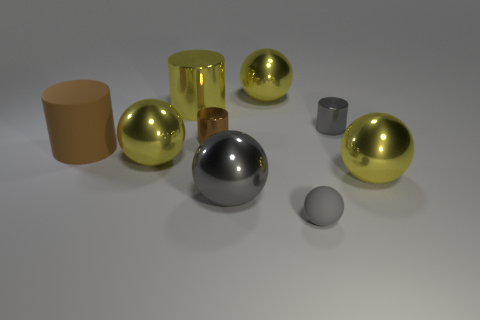Subtract all tiny gray cylinders. How many cylinders are left? 3 Subtract all blue cylinders. Subtract all brown cubes. How many cylinders are left? 4 Subtract all cyan balls. How many purple cylinders are left? 0 Subtract all gray things. Subtract all matte cylinders. How many objects are left? 5 Add 2 brown shiny cylinders. How many brown shiny cylinders are left? 3 Add 4 tiny cyan rubber cubes. How many tiny cyan rubber cubes exist? 4 Subtract all gray cylinders. How many cylinders are left? 3 Subtract 0 green blocks. How many objects are left? 9 Subtract all cylinders. How many objects are left? 5 Subtract 2 cylinders. How many cylinders are left? 2 